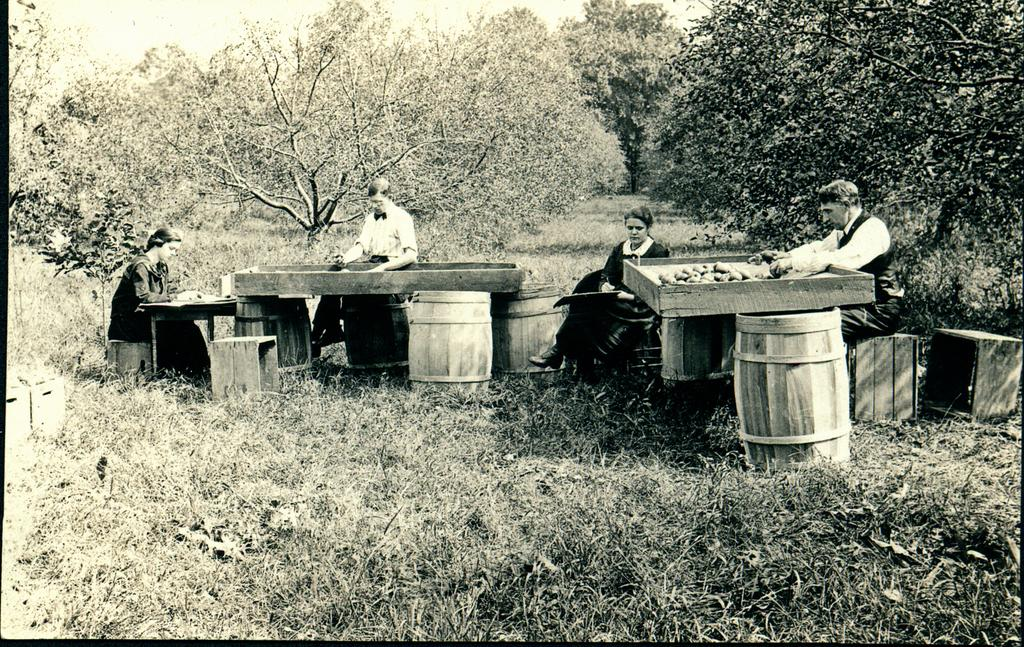What is in the foreground of the image? In the foreground of the image, there is grass, barrels, fruits on wooden trays, and people sitting near the barrels and wooden trays. What type of objects are the people sitting near? The people are sitting near barrels and wooden trays with fruits on them. What can be seen in the background of the image? In the background of the image, there are trees and the sky. What is the primary vegetation in the foreground of the image? The primary vegetation in the foreground of the image is grass. How does the grass in the image affect the people's stomachs? There is no information about the grass affecting the people's stomachs in the image. Is there any poison present in the image? There is no mention of poison in the image. 